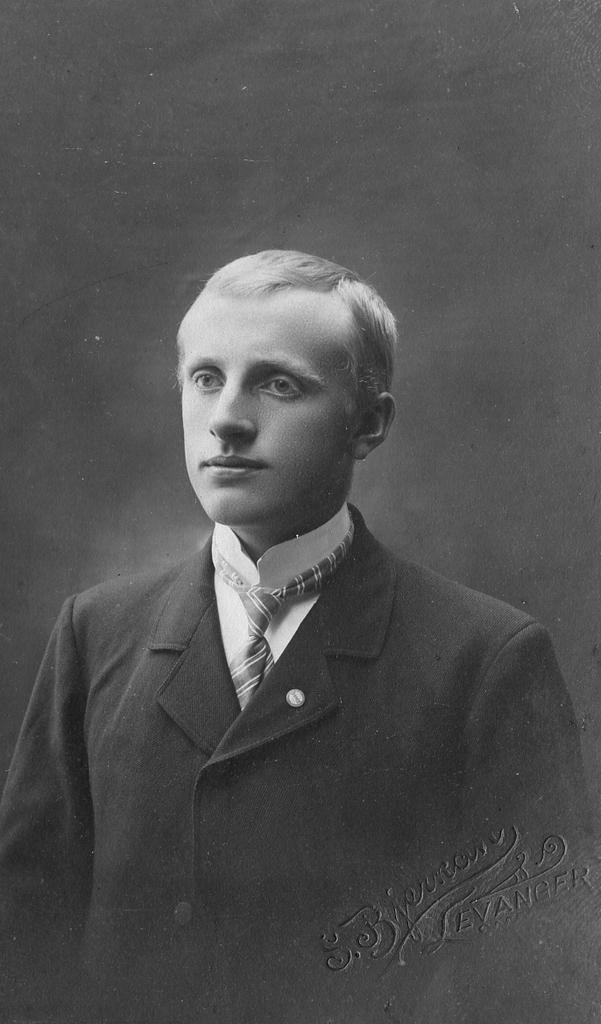Who is the main subject of the image? There is an image of a man in the picture. What color is the background of the image? The background of the image is black. Where is the text located in the image? The text is in the bottom right corner of the picture. What type of cake is being served in the image? There is no cake present in the image; it features an image of a man with a black background and text in the bottom right corner. What month is depicted in the image? There is no month depicted in the image, as it only contains an image of a man, a black background, and text in the bottom right corner. 